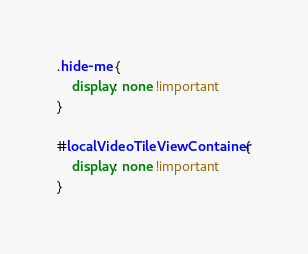Convert code to text. <code><loc_0><loc_0><loc_500><loc_500><_CSS_>.hide-me {
    display: none !important
}

#localVideoTileViewContainer {
    display: none !important
}
</code> 